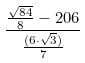Convert formula to latex. <formula><loc_0><loc_0><loc_500><loc_500>\frac { \frac { \sqrt { 8 4 } } { 8 } - 2 0 6 } { \frac { ( 6 \cdot \sqrt { 3 } ) } { 7 } }</formula> 